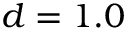Convert formula to latex. <formula><loc_0><loc_0><loc_500><loc_500>d = 1 . 0</formula> 